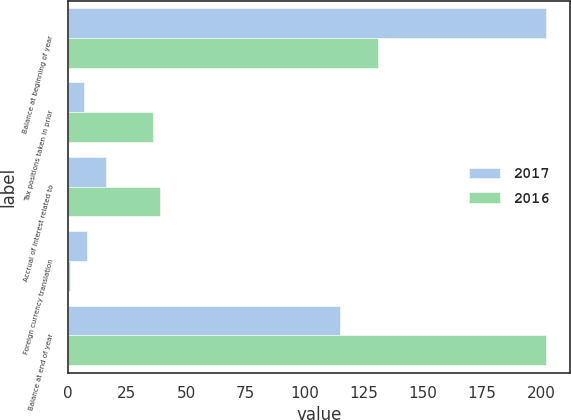<chart> <loc_0><loc_0><loc_500><loc_500><stacked_bar_chart><ecel><fcel>Balance at beginning of year<fcel>Tax positions taken in prior<fcel>Accrual of interest related to<fcel>Foreign currency translation<fcel>Balance at end of year<nl><fcel>2017<fcel>202<fcel>7<fcel>16<fcel>8<fcel>115<nl><fcel>2016<fcel>131<fcel>36<fcel>39<fcel>1<fcel>202<nl></chart> 